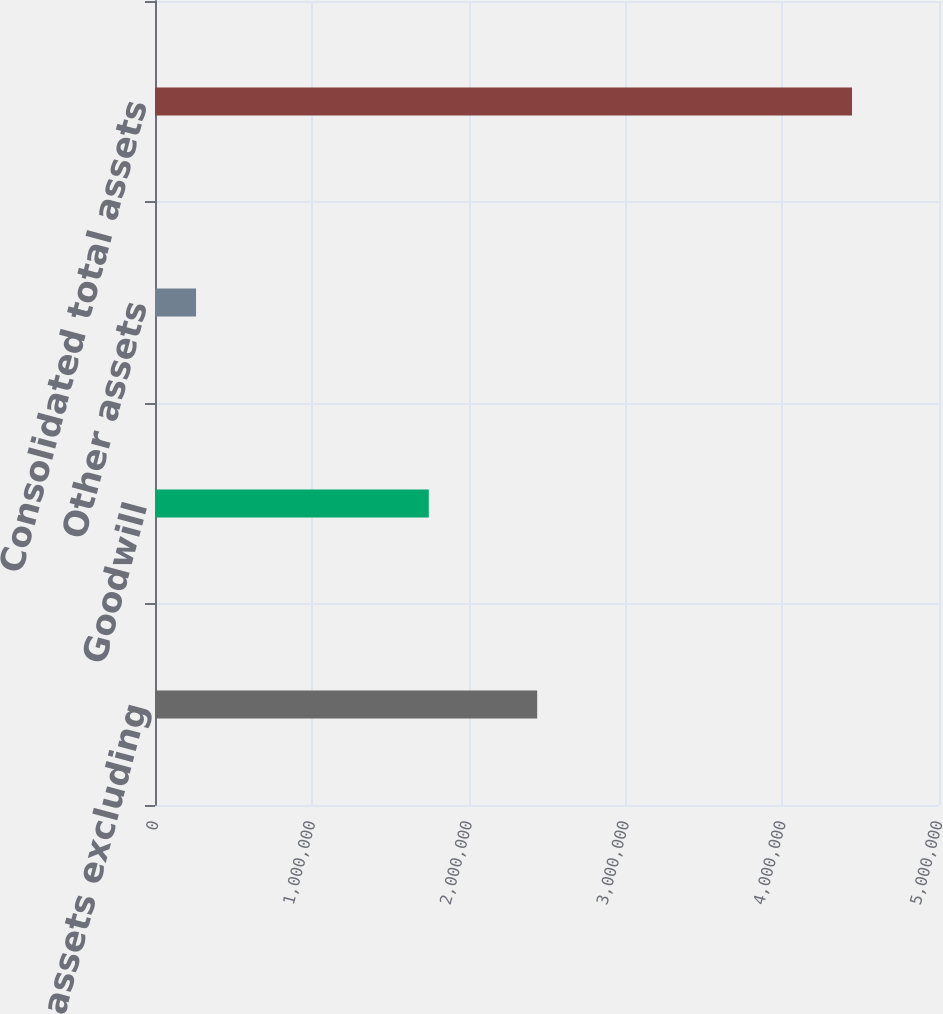Convert chart to OTSL. <chart><loc_0><loc_0><loc_500><loc_500><bar_chart><fcel>Segment assets excluding<fcel>Goodwill<fcel>Other assets<fcel>Consolidated total assets<nl><fcel>2.43741e+06<fcel>1.74611e+06<fcel>261700<fcel>4.44522e+06<nl></chart> 